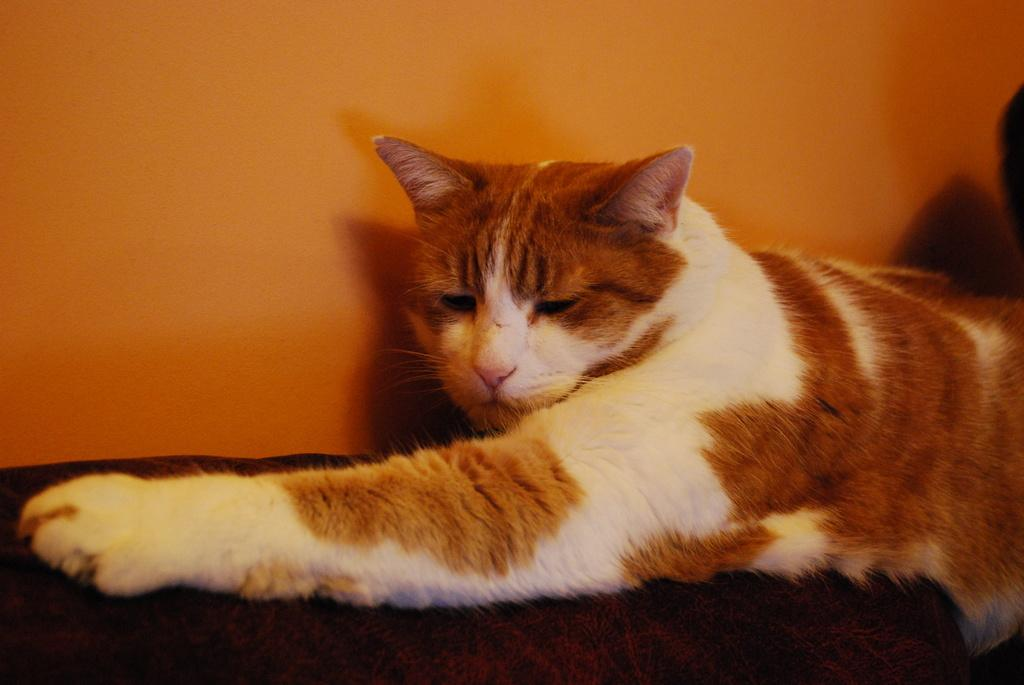What animal is present in the image? There is a cat in the picture. What is the cat doing in the image? The cat is lying on the floor. Can you describe the cat's fur? The cat has white and brown fur. What color is the wall in the background of the picture? There is an orange wall in the background of the picture. How many pipes are visible in the image? There are no pipes present in the image. What emotion does the cat seem to be experiencing in the image? The image does not convey any specific emotion for the cat, so it cannot be determined from the picture. 